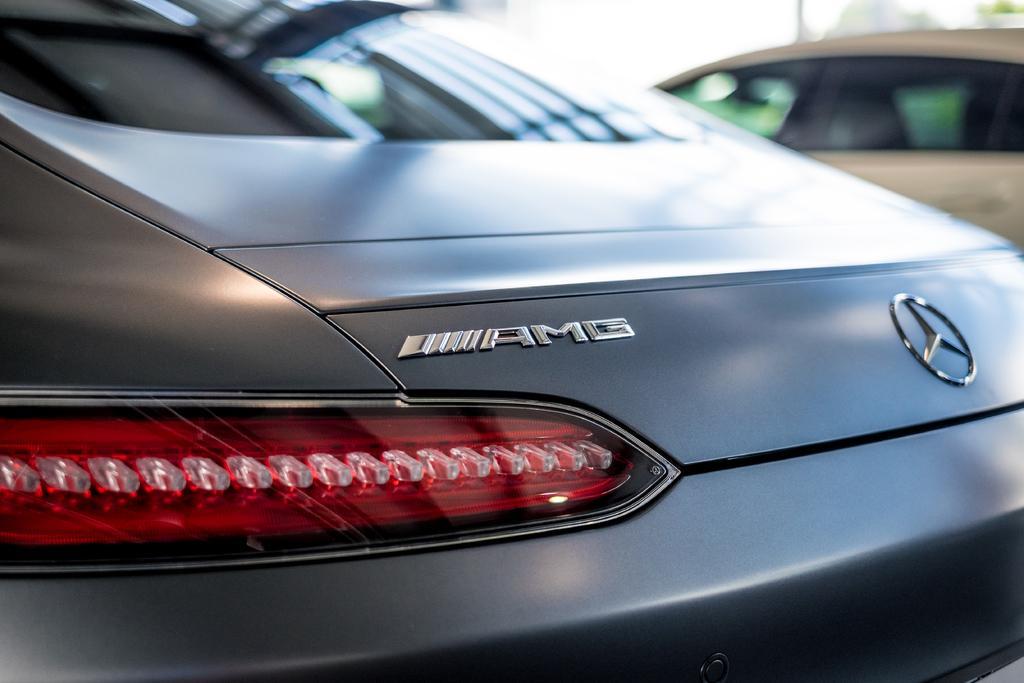How would you summarize this image in a sentence or two? This is the picture of a car to which there is a logo, light and beside there is another car. 